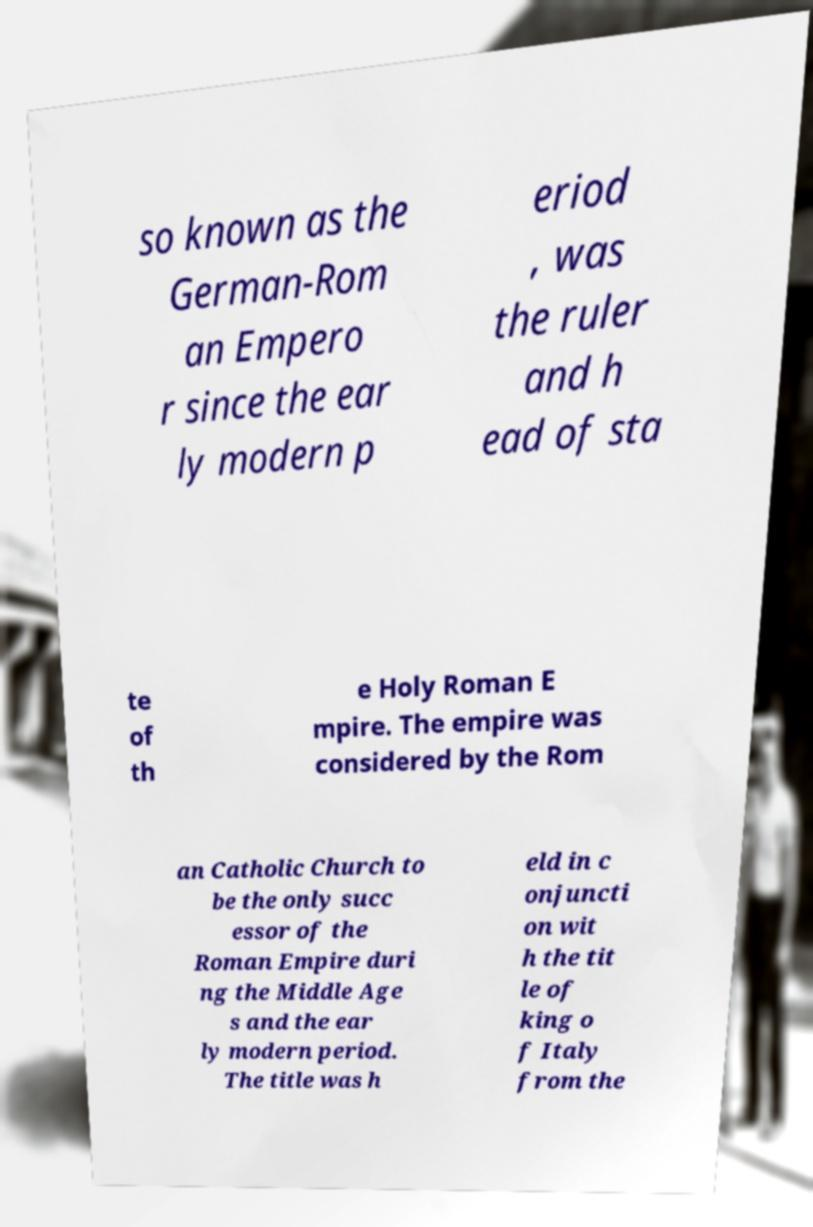Can you read and provide the text displayed in the image?This photo seems to have some interesting text. Can you extract and type it out for me? so known as the German-Rom an Empero r since the ear ly modern p eriod , was the ruler and h ead of sta te of th e Holy Roman E mpire. The empire was considered by the Rom an Catholic Church to be the only succ essor of the Roman Empire duri ng the Middle Age s and the ear ly modern period. The title was h eld in c onjuncti on wit h the tit le of king o f Italy from the 